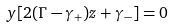Convert formula to latex. <formula><loc_0><loc_0><loc_500><loc_500>y [ 2 ( \Gamma - \gamma _ { + } ) z + \gamma _ { - } ] = 0</formula> 